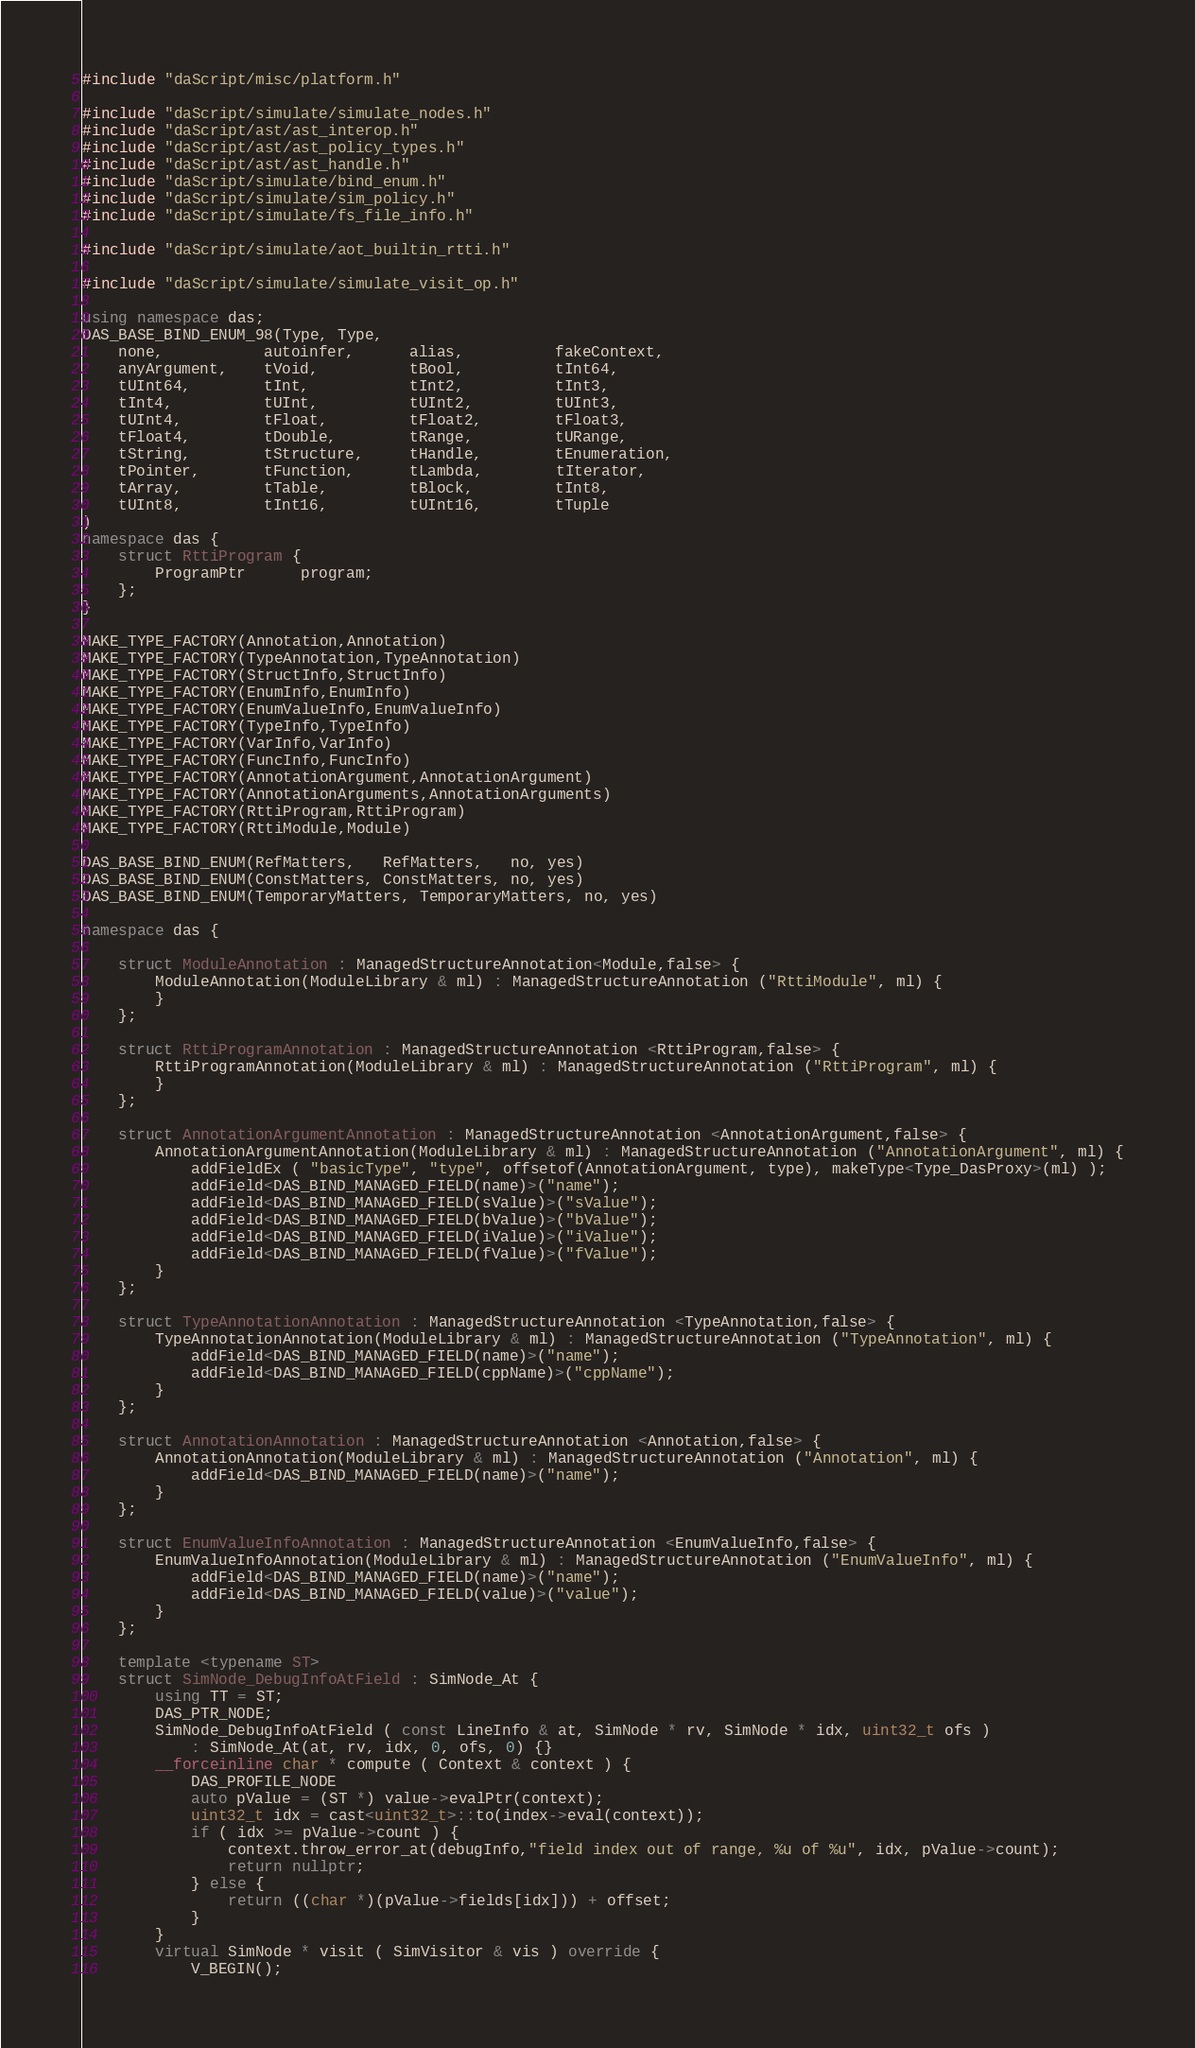Convert code to text. <code><loc_0><loc_0><loc_500><loc_500><_C++_>#include "daScript/misc/platform.h"

#include "daScript/simulate/simulate_nodes.h"
#include "daScript/ast/ast_interop.h"
#include "daScript/ast/ast_policy_types.h"
#include "daScript/ast/ast_handle.h"
#include "daScript/simulate/bind_enum.h"
#include "daScript/simulate/sim_policy.h"
#include "daScript/simulate/fs_file_info.h"

#include "daScript/simulate/aot_builtin_rtti.h"

#include "daScript/simulate/simulate_visit_op.h"

using namespace das;
DAS_BASE_BIND_ENUM_98(Type, Type,
    none,           autoinfer,      alias,          fakeContext,
    anyArgument,    tVoid,          tBool,          tInt64,
    tUInt64,        tInt,           tInt2,          tInt3,
    tInt4,          tUInt,          tUInt2,         tUInt3,
    tUInt4,         tFloat,         tFloat2,        tFloat3,
    tFloat4,        tDouble,        tRange,         tURange,
    tString,        tStructure,     tHandle,        tEnumeration,
    tPointer,       tFunction,      tLambda,        tIterator,
    tArray,         tTable,         tBlock,         tInt8,
    tUInt8,         tInt16,         tUInt16,        tTuple
)
namespace das {
    struct RttiProgram {
        ProgramPtr      program;
    };
}

MAKE_TYPE_FACTORY(Annotation,Annotation)
MAKE_TYPE_FACTORY(TypeAnnotation,TypeAnnotation)
MAKE_TYPE_FACTORY(StructInfo,StructInfo)
MAKE_TYPE_FACTORY(EnumInfo,EnumInfo)
MAKE_TYPE_FACTORY(EnumValueInfo,EnumValueInfo)
MAKE_TYPE_FACTORY(TypeInfo,TypeInfo)
MAKE_TYPE_FACTORY(VarInfo,VarInfo)
MAKE_TYPE_FACTORY(FuncInfo,FuncInfo)
MAKE_TYPE_FACTORY(AnnotationArgument,AnnotationArgument)
MAKE_TYPE_FACTORY(AnnotationArguments,AnnotationArguments)
MAKE_TYPE_FACTORY(RttiProgram,RttiProgram)
MAKE_TYPE_FACTORY(RttiModule,Module)

DAS_BASE_BIND_ENUM(RefMatters,   RefMatters,   no, yes)
DAS_BASE_BIND_ENUM(ConstMatters, ConstMatters, no, yes)
DAS_BASE_BIND_ENUM(TemporaryMatters, TemporaryMatters, no, yes)

namespace das {

    struct ModuleAnnotation : ManagedStructureAnnotation<Module,false> {
        ModuleAnnotation(ModuleLibrary & ml) : ManagedStructureAnnotation ("RttiModule", ml) {
        }
    };

    struct RttiProgramAnnotation : ManagedStructureAnnotation <RttiProgram,false> {
        RttiProgramAnnotation(ModuleLibrary & ml) : ManagedStructureAnnotation ("RttiProgram", ml) {
        }
    };

    struct AnnotationArgumentAnnotation : ManagedStructureAnnotation <AnnotationArgument,false> {
        AnnotationArgumentAnnotation(ModuleLibrary & ml) : ManagedStructureAnnotation ("AnnotationArgument", ml) {
            addFieldEx ( "basicType", "type", offsetof(AnnotationArgument, type), makeType<Type_DasProxy>(ml) );
            addField<DAS_BIND_MANAGED_FIELD(name)>("name");
            addField<DAS_BIND_MANAGED_FIELD(sValue)>("sValue");
            addField<DAS_BIND_MANAGED_FIELD(bValue)>("bValue");
            addField<DAS_BIND_MANAGED_FIELD(iValue)>("iValue");
            addField<DAS_BIND_MANAGED_FIELD(fValue)>("fValue");
        }
    };

    struct TypeAnnotationAnnotation : ManagedStructureAnnotation <TypeAnnotation,false> {
        TypeAnnotationAnnotation(ModuleLibrary & ml) : ManagedStructureAnnotation ("TypeAnnotation", ml) {
            addField<DAS_BIND_MANAGED_FIELD(name)>("name");
            addField<DAS_BIND_MANAGED_FIELD(cppName)>("cppName");
        }
    };

    struct AnnotationAnnotation : ManagedStructureAnnotation <Annotation,false> {
        AnnotationAnnotation(ModuleLibrary & ml) : ManagedStructureAnnotation ("Annotation", ml) {
            addField<DAS_BIND_MANAGED_FIELD(name)>("name");
        }
    };

    struct EnumValueInfoAnnotation : ManagedStructureAnnotation <EnumValueInfo,false> {
        EnumValueInfoAnnotation(ModuleLibrary & ml) : ManagedStructureAnnotation ("EnumValueInfo", ml) {
            addField<DAS_BIND_MANAGED_FIELD(name)>("name");
            addField<DAS_BIND_MANAGED_FIELD(value)>("value");
        }
    };

    template <typename ST>
    struct SimNode_DebugInfoAtField : SimNode_At {
        using TT = ST;
        DAS_PTR_NODE;
        SimNode_DebugInfoAtField ( const LineInfo & at, SimNode * rv, SimNode * idx, uint32_t ofs )
            : SimNode_At(at, rv, idx, 0, ofs, 0) {}
        __forceinline char * compute ( Context & context ) {
            DAS_PROFILE_NODE
            auto pValue = (ST *) value->evalPtr(context);
            uint32_t idx = cast<uint32_t>::to(index->eval(context));
            if ( idx >= pValue->count ) {
                context.throw_error_at(debugInfo,"field index out of range, %u of %u", idx, pValue->count);
                return nullptr;
            } else {
                return ((char *)(pValue->fields[idx])) + offset;
            }
        }
        virtual SimNode * visit ( SimVisitor & vis ) override {
            V_BEGIN();</code> 